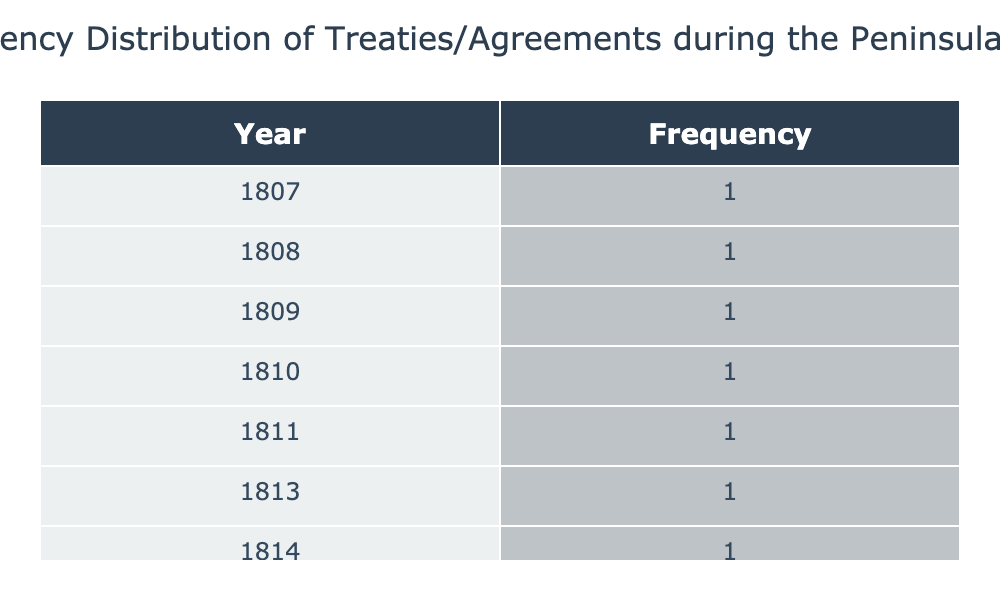What is the most common year for treaties during the Peninsular War? The table shows that each year listed has exactly one treaty or agreement associated with it. Therefore, there is no most common year since every year has the same frequency of one.
Answer: No common year How many treaties were made in total during the Peninsular War? By reviewing the table, there are a total of 7 treaties listed, one for each year from 1807 to 1814.
Answer: 7 Which year had the Treaty of Valençay? Looking at the table, the Treaty of Valençay is listed under the year 1813.
Answer: 1813 What is the average number of treaties made per year during the Peninsular War? Since there are 7 treaties made over the span of 8 years (from 1807 to 1814), the average would be calculated as 7 treaties divided by 8 years, which equals 0.875.
Answer: 0.875 Was there a treaty made in 1810? The table lists a treaty, the Treaty of Ciudad Rodrigo, made in 1810. Thus, the answer is yes.
Answer: Yes How many treaties were made between 1807 and 1811? The treaties for the years 1807, 1808, 1809, and 1811 total 4 treaties. These years correspond to the treaties of Fontainebleau, Bayonne, Hopewell, and Teruel.
Answer: 4 Is there a year without a treaty listed in the table? Every year from 1807 to 1814 has a corresponding treaty or agreement listed. Therefore, the answer is no.
Answer: No In which year were the fewest treaties made? Each year has only one treaty listed, so there is no year with fewer treaties than the others. Hence, all years have the same count.
Answer: None 